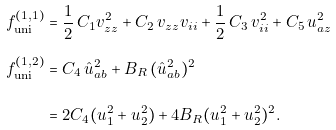<formula> <loc_0><loc_0><loc_500><loc_500>f _ { \text {uni} } ^ { ( 1 , 1 ) } & = \frac { 1 } { 2 } \, C _ { 1 } v _ { z z } ^ { 2 } + C _ { 2 } \, v _ { z z } v _ { i i } + \frac { 1 } { 2 } \, C _ { 3 } \, v _ { i i } ^ { 2 } + C _ { 5 } \, u _ { a z } ^ { 2 } \\ f _ { \text {uni} } ^ { ( 1 , 2 ) } & = C _ { 4 } \, \hat { u } _ { a b } ^ { 2 } + B _ { R } \, ( \hat { u } _ { a b } ^ { 2 } ) ^ { 2 } \\ & = 2 C _ { 4 } ( u _ { 1 } ^ { 2 } + u _ { 2 } ^ { 2 } ) + 4 B _ { R } ( u _ { 1 } ^ { 2 } + u _ { 2 } ^ { 2 } ) ^ { 2 } .</formula> 